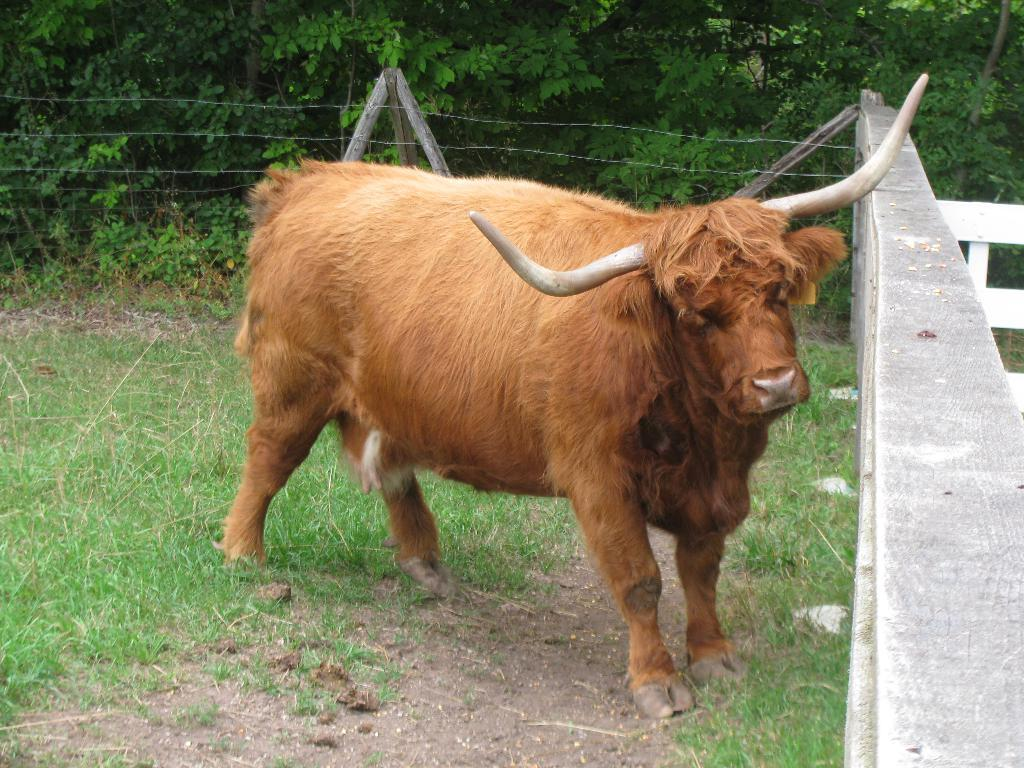What animal is the main subject of the image? There is a bull in the image. What type of vegetation is at the bottom of the image? There is grass at the bottom of the image. What can be seen in the background of the image? There is a fence and trees in the background of the image. What type of discovery was made by the writer in the image? There is no writer or discovery present in the image; it features a bull, grass, a fence, and trees. What type of clover can be seen growing in the image? There is no clover present in the image; it features a bull, grass, a fence, and trees. 